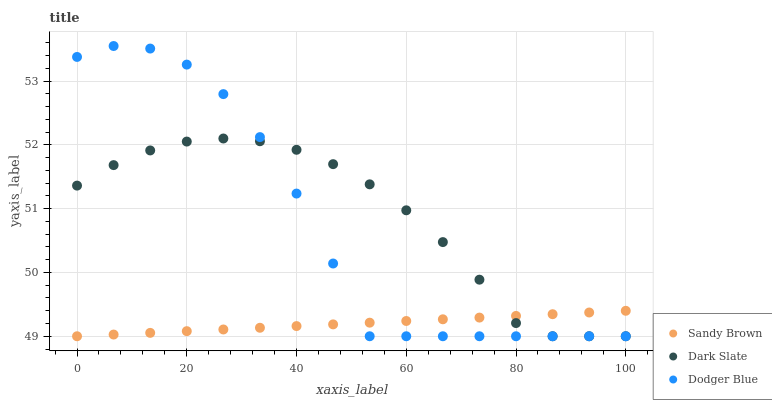Does Sandy Brown have the minimum area under the curve?
Answer yes or no. Yes. Does Dark Slate have the maximum area under the curve?
Answer yes or no. Yes. Does Dodger Blue have the minimum area under the curve?
Answer yes or no. No. Does Dodger Blue have the maximum area under the curve?
Answer yes or no. No. Is Sandy Brown the smoothest?
Answer yes or no. Yes. Is Dodger Blue the roughest?
Answer yes or no. Yes. Is Dodger Blue the smoothest?
Answer yes or no. No. Is Sandy Brown the roughest?
Answer yes or no. No. Does Dark Slate have the lowest value?
Answer yes or no. Yes. Does Dodger Blue have the highest value?
Answer yes or no. Yes. Does Sandy Brown have the highest value?
Answer yes or no. No. Does Dark Slate intersect Dodger Blue?
Answer yes or no. Yes. Is Dark Slate less than Dodger Blue?
Answer yes or no. No. Is Dark Slate greater than Dodger Blue?
Answer yes or no. No. 